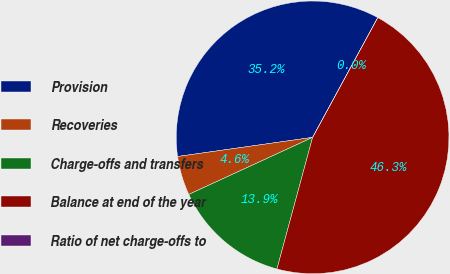Convert chart to OTSL. <chart><loc_0><loc_0><loc_500><loc_500><pie_chart><fcel>Provision<fcel>Recoveries<fcel>Charge-offs and transfers<fcel>Balance at end of the year<fcel>Ratio of net charge-offs to<nl><fcel>35.17%<fcel>4.63%<fcel>13.92%<fcel>46.28%<fcel>0.0%<nl></chart> 